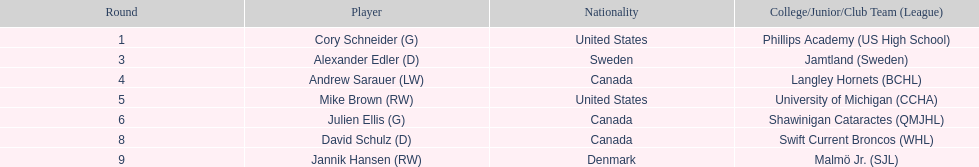Parse the full table. {'header': ['Round', 'Player', 'Nationality', 'College/Junior/Club Team (League)'], 'rows': [['1', 'Cory Schneider (G)', 'United States', 'Phillips Academy (US High School)'], ['3', 'Alexander Edler (D)', 'Sweden', 'Jamtland (Sweden)'], ['4', 'Andrew Sarauer (LW)', 'Canada', 'Langley Hornets (BCHL)'], ['5', 'Mike Brown (RW)', 'United States', 'University of Michigan (CCHA)'], ['6', 'Julien Ellis (G)', 'Canada', 'Shawinigan Cataractes (QMJHL)'], ['8', 'David Schulz (D)', 'Canada', 'Swift Current Broncos (WHL)'], ['9', 'Jannik Hansen (RW)', 'Denmark', 'Malmö Jr. (SJL)']]} The first round not to have a draft pick. 2. 